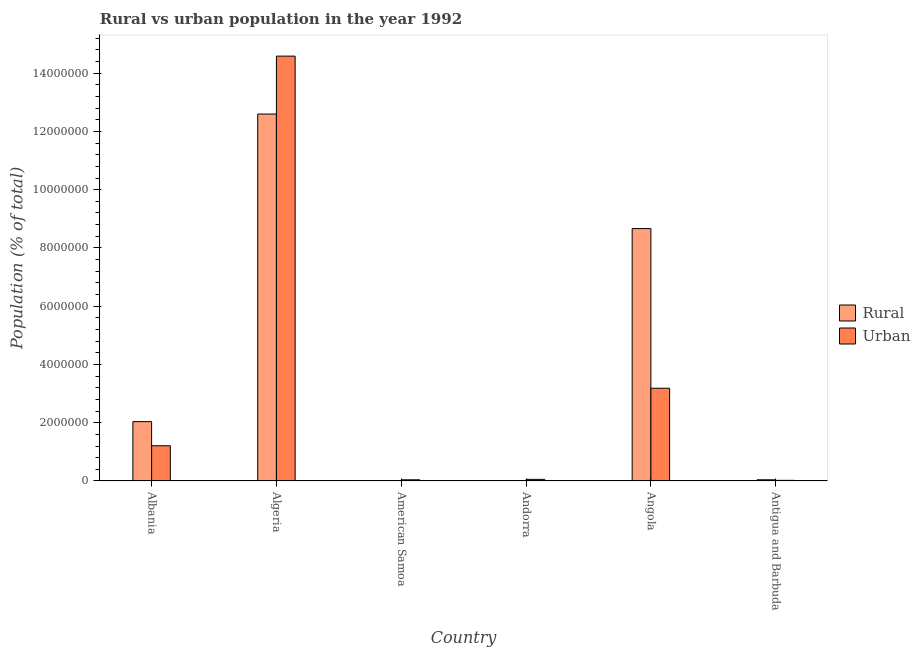How many groups of bars are there?
Ensure brevity in your answer.  6. Are the number of bars on each tick of the X-axis equal?
Make the answer very short. Yes. How many bars are there on the 6th tick from the left?
Ensure brevity in your answer.  2. What is the label of the 2nd group of bars from the left?
Your response must be concise. Algeria. What is the urban population density in Andorra?
Make the answer very short. 5.56e+04. Across all countries, what is the maximum urban population density?
Provide a succinct answer. 1.46e+07. Across all countries, what is the minimum urban population density?
Your answer should be compact. 2.23e+04. In which country was the rural population density maximum?
Your response must be concise. Algeria. In which country was the urban population density minimum?
Ensure brevity in your answer.  Antigua and Barbuda. What is the total urban population density in the graph?
Offer a terse response. 1.91e+07. What is the difference between the urban population density in Albania and that in Antigua and Barbuda?
Your answer should be compact. 1.19e+06. What is the difference between the urban population density in Antigua and Barbuda and the rural population density in Andorra?
Offer a very short reply. 1.89e+04. What is the average rural population density per country?
Provide a succinct answer. 3.89e+06. What is the difference between the urban population density and rural population density in Antigua and Barbuda?
Keep it short and to the point. -1.89e+04. In how many countries, is the urban population density greater than 4400000 %?
Offer a very short reply. 1. What is the ratio of the rural population density in American Samoa to that in Andorra?
Offer a terse response. 2.55. Is the difference between the rural population density in Albania and Algeria greater than the difference between the urban population density in Albania and Algeria?
Provide a short and direct response. Yes. What is the difference between the highest and the second highest urban population density?
Keep it short and to the point. 1.14e+07. What is the difference between the highest and the lowest rural population density?
Offer a terse response. 1.26e+07. In how many countries, is the urban population density greater than the average urban population density taken over all countries?
Your answer should be compact. 2. Is the sum of the urban population density in American Samoa and Angola greater than the maximum rural population density across all countries?
Provide a short and direct response. No. What does the 2nd bar from the left in Albania represents?
Provide a succinct answer. Urban. What does the 2nd bar from the right in Algeria represents?
Offer a very short reply. Rural. How many countries are there in the graph?
Make the answer very short. 6. Are the values on the major ticks of Y-axis written in scientific E-notation?
Make the answer very short. No. Does the graph contain any zero values?
Offer a very short reply. No. Where does the legend appear in the graph?
Keep it short and to the point. Center right. How are the legend labels stacked?
Ensure brevity in your answer.  Vertical. What is the title of the graph?
Your response must be concise. Rural vs urban population in the year 1992. Does "Male labor force" appear as one of the legend labels in the graph?
Make the answer very short. No. What is the label or title of the X-axis?
Offer a terse response. Country. What is the label or title of the Y-axis?
Your response must be concise. Population (% of total). What is the Population (% of total) of Rural in Albania?
Keep it short and to the point. 2.04e+06. What is the Population (% of total) in Urban in Albania?
Provide a succinct answer. 1.21e+06. What is the Population (% of total) of Rural in Algeria?
Ensure brevity in your answer.  1.26e+07. What is the Population (% of total) in Urban in Algeria?
Give a very brief answer. 1.46e+07. What is the Population (% of total) of Rural in American Samoa?
Provide a succinct answer. 8536. What is the Population (% of total) of Urban in American Samoa?
Offer a terse response. 4.11e+04. What is the Population (% of total) in Rural in Andorra?
Keep it short and to the point. 3343. What is the Population (% of total) of Urban in Andorra?
Ensure brevity in your answer.  5.56e+04. What is the Population (% of total) of Rural in Angola?
Keep it short and to the point. 8.66e+06. What is the Population (% of total) in Urban in Angola?
Your answer should be compact. 3.18e+06. What is the Population (% of total) of Rural in Antigua and Barbuda?
Offer a very short reply. 4.12e+04. What is the Population (% of total) of Urban in Antigua and Barbuda?
Provide a short and direct response. 2.23e+04. Across all countries, what is the maximum Population (% of total) in Rural?
Ensure brevity in your answer.  1.26e+07. Across all countries, what is the maximum Population (% of total) in Urban?
Ensure brevity in your answer.  1.46e+07. Across all countries, what is the minimum Population (% of total) in Rural?
Provide a succinct answer. 3343. Across all countries, what is the minimum Population (% of total) in Urban?
Offer a very short reply. 2.23e+04. What is the total Population (% of total) of Rural in the graph?
Make the answer very short. 2.34e+07. What is the total Population (% of total) in Urban in the graph?
Your answer should be compact. 1.91e+07. What is the difference between the Population (% of total) in Rural in Albania and that in Algeria?
Offer a very short reply. -1.06e+07. What is the difference between the Population (% of total) in Urban in Albania and that in Algeria?
Ensure brevity in your answer.  -1.34e+07. What is the difference between the Population (% of total) in Rural in Albania and that in American Samoa?
Your answer should be very brief. 2.03e+06. What is the difference between the Population (% of total) of Urban in Albania and that in American Samoa?
Offer a very short reply. 1.17e+06. What is the difference between the Population (% of total) of Rural in Albania and that in Andorra?
Offer a very short reply. 2.03e+06. What is the difference between the Population (% of total) in Urban in Albania and that in Andorra?
Ensure brevity in your answer.  1.15e+06. What is the difference between the Population (% of total) of Rural in Albania and that in Angola?
Give a very brief answer. -6.63e+06. What is the difference between the Population (% of total) in Urban in Albania and that in Angola?
Your answer should be compact. -1.97e+06. What is the difference between the Population (% of total) of Rural in Albania and that in Antigua and Barbuda?
Your response must be concise. 2.00e+06. What is the difference between the Population (% of total) of Urban in Albania and that in Antigua and Barbuda?
Make the answer very short. 1.19e+06. What is the difference between the Population (% of total) in Rural in Algeria and that in American Samoa?
Make the answer very short. 1.26e+07. What is the difference between the Population (% of total) of Urban in Algeria and that in American Samoa?
Give a very brief answer. 1.45e+07. What is the difference between the Population (% of total) of Rural in Algeria and that in Andorra?
Your answer should be very brief. 1.26e+07. What is the difference between the Population (% of total) of Urban in Algeria and that in Andorra?
Make the answer very short. 1.45e+07. What is the difference between the Population (% of total) of Rural in Algeria and that in Angola?
Provide a succinct answer. 3.93e+06. What is the difference between the Population (% of total) in Urban in Algeria and that in Angola?
Your answer should be very brief. 1.14e+07. What is the difference between the Population (% of total) in Rural in Algeria and that in Antigua and Barbuda?
Your answer should be compact. 1.26e+07. What is the difference between the Population (% of total) of Urban in Algeria and that in Antigua and Barbuda?
Give a very brief answer. 1.46e+07. What is the difference between the Population (% of total) of Rural in American Samoa and that in Andorra?
Give a very brief answer. 5193. What is the difference between the Population (% of total) of Urban in American Samoa and that in Andorra?
Your response must be concise. -1.45e+04. What is the difference between the Population (% of total) of Rural in American Samoa and that in Angola?
Provide a succinct answer. -8.66e+06. What is the difference between the Population (% of total) in Urban in American Samoa and that in Angola?
Your answer should be very brief. -3.14e+06. What is the difference between the Population (% of total) of Rural in American Samoa and that in Antigua and Barbuda?
Your response must be concise. -3.26e+04. What is the difference between the Population (% of total) of Urban in American Samoa and that in Antigua and Barbuda?
Keep it short and to the point. 1.88e+04. What is the difference between the Population (% of total) in Rural in Andorra and that in Angola?
Ensure brevity in your answer.  -8.66e+06. What is the difference between the Population (% of total) of Urban in Andorra and that in Angola?
Your response must be concise. -3.13e+06. What is the difference between the Population (% of total) in Rural in Andorra and that in Antigua and Barbuda?
Make the answer very short. -3.78e+04. What is the difference between the Population (% of total) of Urban in Andorra and that in Antigua and Barbuda?
Give a very brief answer. 3.33e+04. What is the difference between the Population (% of total) of Rural in Angola and that in Antigua and Barbuda?
Your answer should be compact. 8.62e+06. What is the difference between the Population (% of total) of Urban in Angola and that in Antigua and Barbuda?
Offer a very short reply. 3.16e+06. What is the difference between the Population (% of total) in Rural in Albania and the Population (% of total) in Urban in Algeria?
Your answer should be very brief. -1.25e+07. What is the difference between the Population (% of total) in Rural in Albania and the Population (% of total) in Urban in American Samoa?
Give a very brief answer. 2.00e+06. What is the difference between the Population (% of total) of Rural in Albania and the Population (% of total) of Urban in Andorra?
Your answer should be compact. 1.98e+06. What is the difference between the Population (% of total) of Rural in Albania and the Population (% of total) of Urban in Angola?
Offer a terse response. -1.15e+06. What is the difference between the Population (% of total) in Rural in Albania and the Population (% of total) in Urban in Antigua and Barbuda?
Your response must be concise. 2.02e+06. What is the difference between the Population (% of total) in Rural in Algeria and the Population (% of total) in Urban in American Samoa?
Offer a terse response. 1.26e+07. What is the difference between the Population (% of total) in Rural in Algeria and the Population (% of total) in Urban in Andorra?
Ensure brevity in your answer.  1.25e+07. What is the difference between the Population (% of total) in Rural in Algeria and the Population (% of total) in Urban in Angola?
Make the answer very short. 9.41e+06. What is the difference between the Population (% of total) of Rural in Algeria and the Population (% of total) of Urban in Antigua and Barbuda?
Give a very brief answer. 1.26e+07. What is the difference between the Population (% of total) in Rural in American Samoa and the Population (% of total) in Urban in Andorra?
Keep it short and to the point. -4.70e+04. What is the difference between the Population (% of total) in Rural in American Samoa and the Population (% of total) in Urban in Angola?
Offer a terse response. -3.18e+06. What is the difference between the Population (% of total) in Rural in American Samoa and the Population (% of total) in Urban in Antigua and Barbuda?
Provide a short and direct response. -1.37e+04. What is the difference between the Population (% of total) of Rural in Andorra and the Population (% of total) of Urban in Angola?
Keep it short and to the point. -3.18e+06. What is the difference between the Population (% of total) of Rural in Andorra and the Population (% of total) of Urban in Antigua and Barbuda?
Give a very brief answer. -1.89e+04. What is the difference between the Population (% of total) of Rural in Angola and the Population (% of total) of Urban in Antigua and Barbuda?
Your answer should be very brief. 8.64e+06. What is the average Population (% of total) of Rural per country?
Your answer should be compact. 3.89e+06. What is the average Population (% of total) in Urban per country?
Ensure brevity in your answer.  3.18e+06. What is the difference between the Population (% of total) of Rural and Population (% of total) of Urban in Albania?
Provide a short and direct response. 8.28e+05. What is the difference between the Population (% of total) of Rural and Population (% of total) of Urban in Algeria?
Provide a succinct answer. -1.99e+06. What is the difference between the Population (% of total) of Rural and Population (% of total) of Urban in American Samoa?
Offer a terse response. -3.25e+04. What is the difference between the Population (% of total) of Rural and Population (% of total) of Urban in Andorra?
Give a very brief answer. -5.22e+04. What is the difference between the Population (% of total) in Rural and Population (% of total) in Urban in Angola?
Provide a succinct answer. 5.48e+06. What is the difference between the Population (% of total) in Rural and Population (% of total) in Urban in Antigua and Barbuda?
Keep it short and to the point. 1.89e+04. What is the ratio of the Population (% of total) in Rural in Albania to that in Algeria?
Provide a succinct answer. 0.16. What is the ratio of the Population (% of total) in Urban in Albania to that in Algeria?
Provide a short and direct response. 0.08. What is the ratio of the Population (% of total) of Rural in Albania to that in American Samoa?
Your answer should be very brief. 238.7. What is the ratio of the Population (% of total) in Urban in Albania to that in American Samoa?
Offer a very short reply. 29.46. What is the ratio of the Population (% of total) of Rural in Albania to that in Andorra?
Your response must be concise. 609.5. What is the ratio of the Population (% of total) of Urban in Albania to that in Andorra?
Give a very brief answer. 21.77. What is the ratio of the Population (% of total) of Rural in Albania to that in Angola?
Offer a very short reply. 0.24. What is the ratio of the Population (% of total) of Urban in Albania to that in Angola?
Make the answer very short. 0.38. What is the ratio of the Population (% of total) of Rural in Albania to that in Antigua and Barbuda?
Keep it short and to the point. 49.48. What is the ratio of the Population (% of total) of Urban in Albania to that in Antigua and Barbuda?
Provide a short and direct response. 54.34. What is the ratio of the Population (% of total) in Rural in Algeria to that in American Samoa?
Provide a succinct answer. 1475.69. What is the ratio of the Population (% of total) in Urban in Algeria to that in American Samoa?
Keep it short and to the point. 355.19. What is the ratio of the Population (% of total) of Rural in Algeria to that in Andorra?
Keep it short and to the point. 3768.01. What is the ratio of the Population (% of total) in Urban in Algeria to that in Andorra?
Your answer should be compact. 262.49. What is the ratio of the Population (% of total) of Rural in Algeria to that in Angola?
Offer a terse response. 1.45. What is the ratio of the Population (% of total) of Urban in Algeria to that in Angola?
Keep it short and to the point. 4.58. What is the ratio of the Population (% of total) of Rural in Algeria to that in Antigua and Barbuda?
Keep it short and to the point. 305.9. What is the ratio of the Population (% of total) of Urban in Algeria to that in Antigua and Barbuda?
Provide a short and direct response. 655.3. What is the ratio of the Population (% of total) in Rural in American Samoa to that in Andorra?
Ensure brevity in your answer.  2.55. What is the ratio of the Population (% of total) in Urban in American Samoa to that in Andorra?
Provide a short and direct response. 0.74. What is the ratio of the Population (% of total) of Rural in American Samoa to that in Angola?
Provide a short and direct response. 0. What is the ratio of the Population (% of total) of Urban in American Samoa to that in Angola?
Your answer should be compact. 0.01. What is the ratio of the Population (% of total) of Rural in American Samoa to that in Antigua and Barbuda?
Give a very brief answer. 0.21. What is the ratio of the Population (% of total) of Urban in American Samoa to that in Antigua and Barbuda?
Provide a short and direct response. 1.84. What is the ratio of the Population (% of total) in Urban in Andorra to that in Angola?
Make the answer very short. 0.02. What is the ratio of the Population (% of total) in Rural in Andorra to that in Antigua and Barbuda?
Your answer should be compact. 0.08. What is the ratio of the Population (% of total) of Urban in Andorra to that in Antigua and Barbuda?
Offer a very short reply. 2.5. What is the ratio of the Population (% of total) in Rural in Angola to that in Antigua and Barbuda?
Offer a very short reply. 210.43. What is the ratio of the Population (% of total) in Urban in Angola to that in Antigua and Barbuda?
Offer a very short reply. 143.06. What is the difference between the highest and the second highest Population (% of total) in Rural?
Give a very brief answer. 3.93e+06. What is the difference between the highest and the second highest Population (% of total) in Urban?
Offer a very short reply. 1.14e+07. What is the difference between the highest and the lowest Population (% of total) in Rural?
Your answer should be compact. 1.26e+07. What is the difference between the highest and the lowest Population (% of total) in Urban?
Your answer should be very brief. 1.46e+07. 